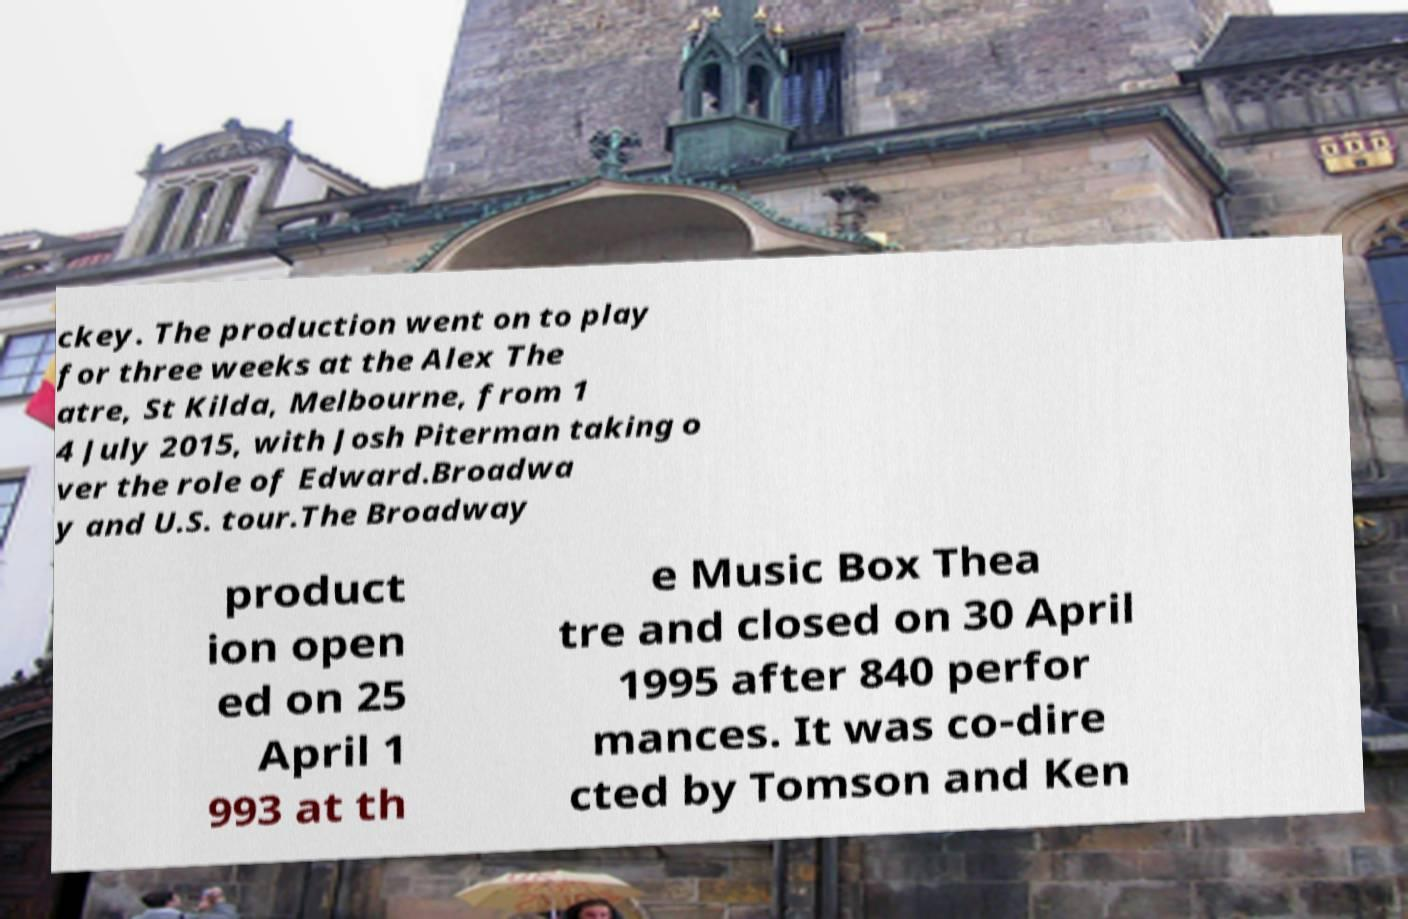Please read and relay the text visible in this image. What does it say? ckey. The production went on to play for three weeks at the Alex The atre, St Kilda, Melbourne, from 1 4 July 2015, with Josh Piterman taking o ver the role of Edward.Broadwa y and U.S. tour.The Broadway product ion open ed on 25 April 1 993 at th e Music Box Thea tre and closed on 30 April 1995 after 840 perfor mances. It was co-dire cted by Tomson and Ken 